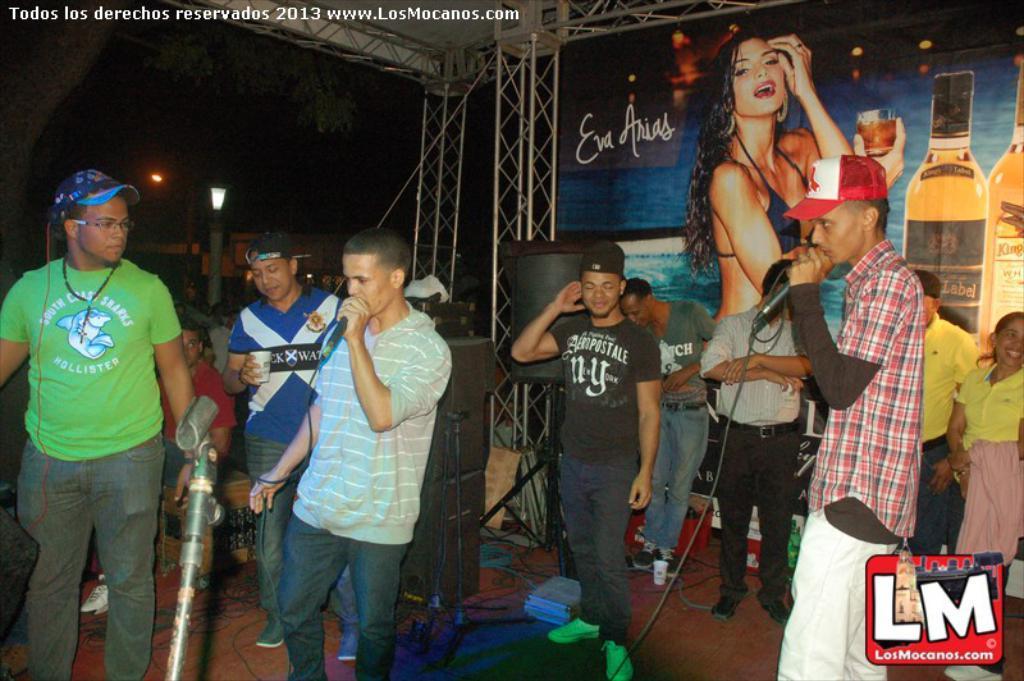Please provide a concise description of this image. In this picture there are two boys on the right and left side of the image, by holding mics in their hands and there are other people in the background area of the image and there is a poster and speakers in the image, there are towers and lamps in the image. 